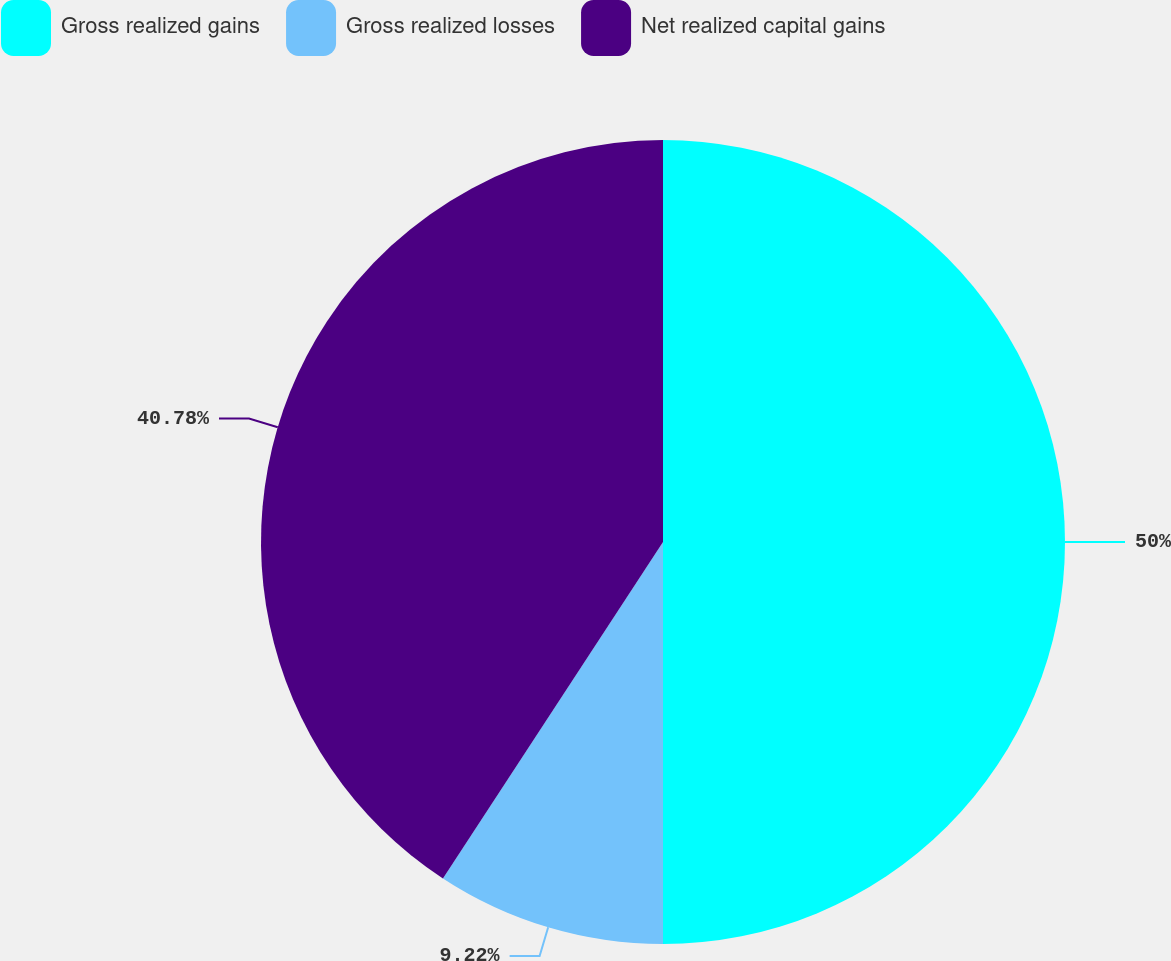Convert chart to OTSL. <chart><loc_0><loc_0><loc_500><loc_500><pie_chart><fcel>Gross realized gains<fcel>Gross realized losses<fcel>Net realized capital gains<nl><fcel>50.0%<fcel>9.22%<fcel>40.78%<nl></chart> 